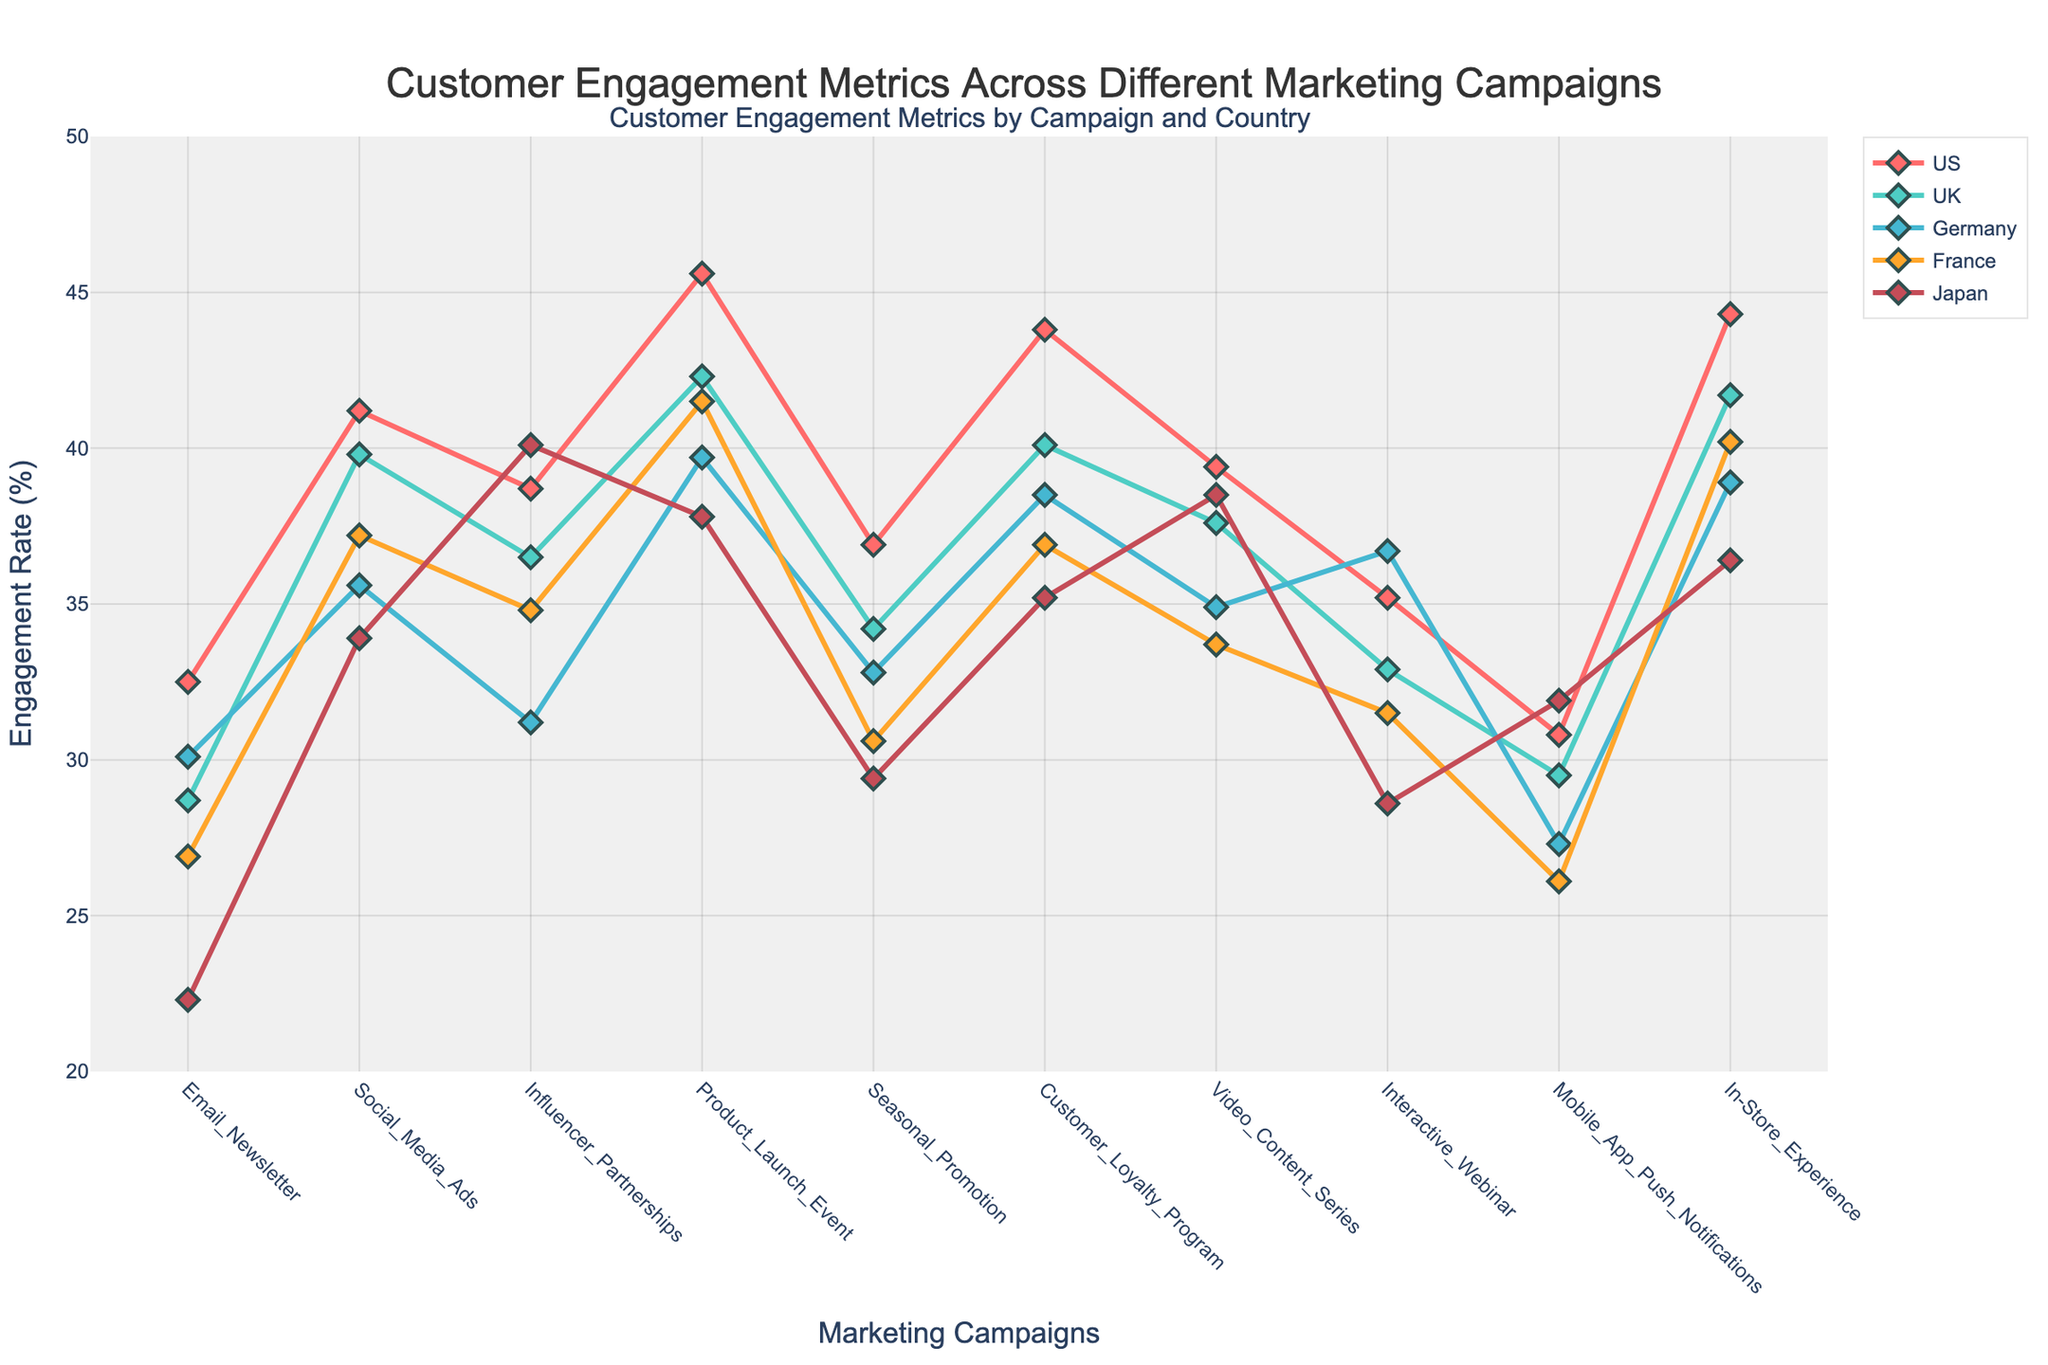What's the highest engagement rate across all campaigns for the US? Look at the line corresponding to the US and find the highest point on the y-axis. The highest engagement rate for the US is at the 'Product_Launch_Event' campaign.
Answer: 45.6% How does the engagement for the 'Interactive_Webinar' campaign compare to the 'Email_Newsletter' campaign for Japan? Locate the points for 'Interactive_Webinar' and 'Email_Newsletter' for Japan on the figure. The engagement rate for 'Interactive_Webinar' (28.6%) is higher than 'Email_Newsletter' (22.3%).
Answer: Higher Which country has the lowest engagement rate during the 'Video_Content_Series' campaign? Identify the engagement values for 'Video_Content_Series' across all countries and find the lowest one. France has the lowest engagement rate during the 'Video_Content_Series' campaign with 33.7%.
Answer: France Calculate the average engagement rate for Germany across all campaigns. Sum the engagement rates of all campaigns for Germany and then divide by the number of campaigns: (30.1 + 35.6 + 31.2 + 39.7 + 32.8 + 38.5 + 34.9 + 36.7 + 27.3 + 38.9) / 10 = 34.57.
Answer: 34.57% Which marketing campaign has the closest engagement rates between the US and UK? Calculate the absolute difference in engagement rate between US and UK for each campaign and determine which one is smallest. The 'In-Store_Experience' campaign has a difference of 2.6% which is the closest.
Answer: In-Store_Experience Which campaign had the highest engagement rate in Japan? Look at the data points for Japan across all campaigns and find the highest point. The 'Influencer_Partnerships' campaign has the highest engagement rate at 40.1%.
Answer: Influencer_Partnerships For the 'Seasonal_Promotion' campaign, which country had the highest engagement rate and which had the lowest? Identify the engagement values for 'Seasonal_Promotion' and determine the country with the highest and lowest values. The highest is the US with 36.9%, and the lowest is Japan with 29.4%.
Answer: Highest: US, Lowest: Japan What's the engagement rate difference between 'Customer_Loyalty_Program' and 'Mobile_App_Push_Notifications' in France? Locate the engagement rates for both campaigns in France and subtract the engagement rate of 'Mobile_App_Push_Notifications' (26.1%) from the 'Customer_Loyalty_Program' (36.9%): 36.9 - 26.1 = 10.8%.
Answer: 10.8% Which country's engagement rate shows the least fluctuation across different campaigns? Visually assess the stability of lines for each country. The UK shows the least fluctuation as it has a relatively smooth line with small peaks and troughs.
Answer: UK 